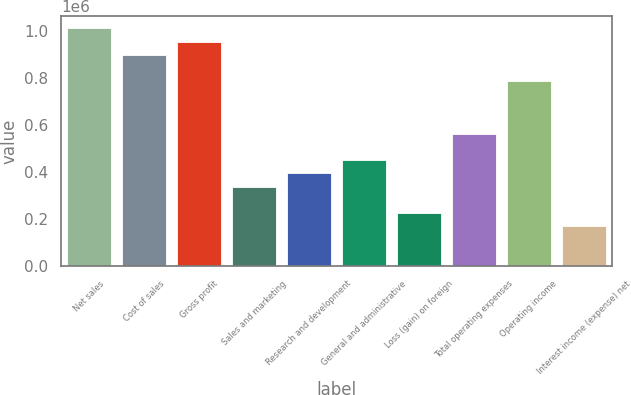<chart> <loc_0><loc_0><loc_500><loc_500><bar_chart><fcel>Net sales<fcel>Cost of sales<fcel>Gross profit<fcel>Sales and marketing<fcel>Research and development<fcel>General and administrative<fcel>Loss (gain) on foreign<fcel>Total operating expenses<fcel>Operating income<fcel>Interest income (expense) net<nl><fcel>1.01255e+06<fcel>900043<fcel>956296<fcel>337518<fcel>393770<fcel>450023<fcel>225013<fcel>562528<fcel>787538<fcel>168760<nl></chart> 